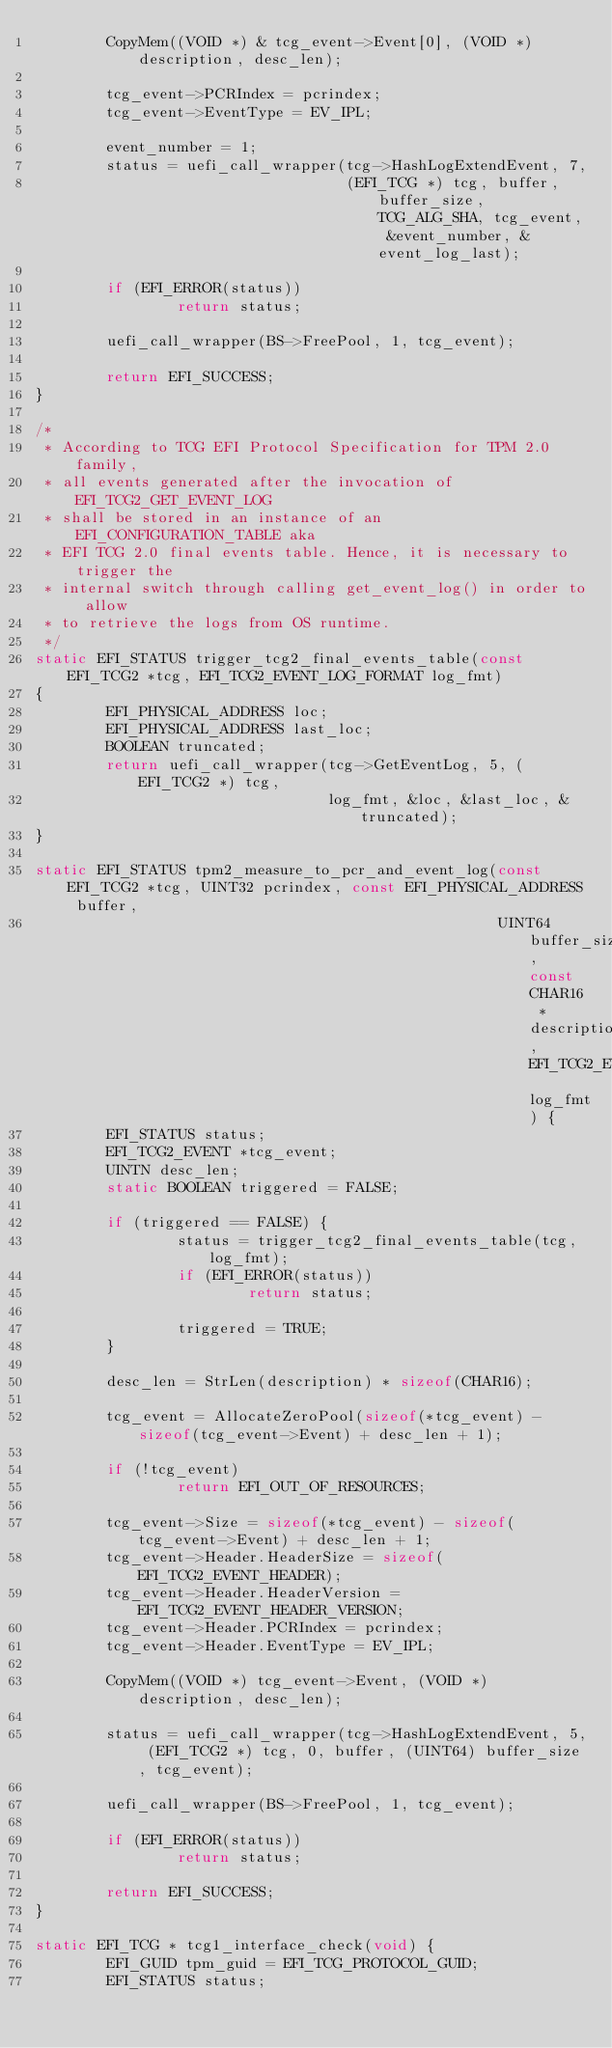<code> <loc_0><loc_0><loc_500><loc_500><_C_>        CopyMem((VOID *) & tcg_event->Event[0], (VOID *) description, desc_len);

        tcg_event->PCRIndex = pcrindex;
        tcg_event->EventType = EV_IPL;

        event_number = 1;
        status = uefi_call_wrapper(tcg->HashLogExtendEvent, 7,
                                   (EFI_TCG *) tcg, buffer, buffer_size, TCG_ALG_SHA, tcg_event, &event_number, &event_log_last);

        if (EFI_ERROR(status))
                return status;

        uefi_call_wrapper(BS->FreePool, 1, tcg_event);

        return EFI_SUCCESS;
}

/*
 * According to TCG EFI Protocol Specification for TPM 2.0 family,
 * all events generated after the invocation of EFI_TCG2_GET_EVENT_LOG
 * shall be stored in an instance of an EFI_CONFIGURATION_TABLE aka
 * EFI TCG 2.0 final events table. Hence, it is necessary to trigger the
 * internal switch through calling get_event_log() in order to allow
 * to retrieve the logs from OS runtime.
 */
static EFI_STATUS trigger_tcg2_final_events_table(const EFI_TCG2 *tcg, EFI_TCG2_EVENT_LOG_FORMAT log_fmt)
{
        EFI_PHYSICAL_ADDRESS loc;
        EFI_PHYSICAL_ADDRESS last_loc;
        BOOLEAN truncated;
        return uefi_call_wrapper(tcg->GetEventLog, 5, (EFI_TCG2 *) tcg,
                                 log_fmt, &loc, &last_loc, &truncated);
}

static EFI_STATUS tpm2_measure_to_pcr_and_event_log(const EFI_TCG2 *tcg, UINT32 pcrindex, const EFI_PHYSICAL_ADDRESS buffer,
                                                    UINT64 buffer_size, const CHAR16 *description, EFI_TCG2_EVENT_LOG_FORMAT log_fmt) {
        EFI_STATUS status;
        EFI_TCG2_EVENT *tcg_event;
        UINTN desc_len;
        static BOOLEAN triggered = FALSE;

        if (triggered == FALSE) {
                status = trigger_tcg2_final_events_table(tcg, log_fmt);
                if (EFI_ERROR(status))
                        return status;

                triggered = TRUE;
        }

        desc_len = StrLen(description) * sizeof(CHAR16);

        tcg_event = AllocateZeroPool(sizeof(*tcg_event) - sizeof(tcg_event->Event) + desc_len + 1);

        if (!tcg_event)
                return EFI_OUT_OF_RESOURCES;

        tcg_event->Size = sizeof(*tcg_event) - sizeof(tcg_event->Event) + desc_len + 1;
        tcg_event->Header.HeaderSize = sizeof(EFI_TCG2_EVENT_HEADER);
        tcg_event->Header.HeaderVersion = EFI_TCG2_EVENT_HEADER_VERSION;
        tcg_event->Header.PCRIndex = pcrindex;
        tcg_event->Header.EventType = EV_IPL;

        CopyMem((VOID *) tcg_event->Event, (VOID *) description, desc_len);

        status = uefi_call_wrapper(tcg->HashLogExtendEvent, 5, (EFI_TCG2 *) tcg, 0, buffer, (UINT64) buffer_size, tcg_event);

        uefi_call_wrapper(BS->FreePool, 1, tcg_event);

        if (EFI_ERROR(status))
                return status;

        return EFI_SUCCESS;
}

static EFI_TCG * tcg1_interface_check(void) {
        EFI_GUID tpm_guid = EFI_TCG_PROTOCOL_GUID;
        EFI_STATUS status;</code> 